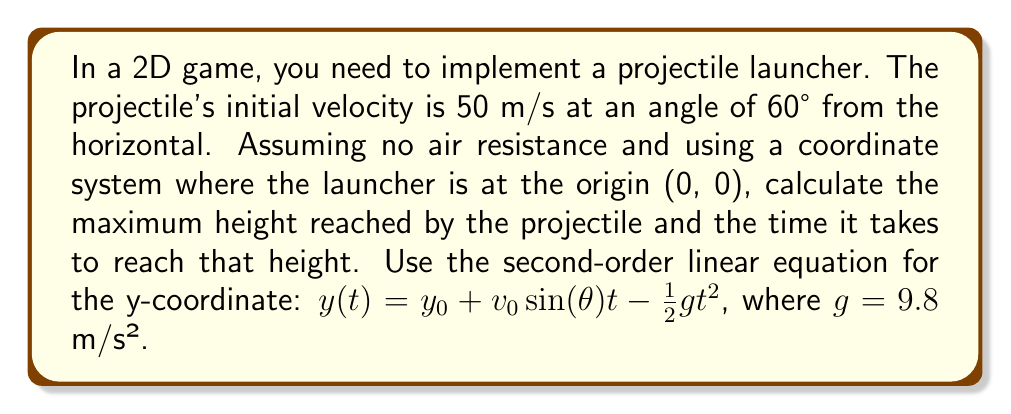Can you solve this math problem? To solve this problem, we'll use the second-order linear equation for the y-coordinate of a projectile:

$$y(t) = y_0 + v_0\sin(\theta)t - \frac{1}{2}gt^2$$

Where:
- $y_0$ is the initial height (0 m in this case)
- $v_0$ is the initial velocity (50 m/s)
- $\theta$ is the launch angle (60°)
- $g$ is the acceleration due to gravity (9.8 m/s²)
- $t$ is time

Step 1: Calculate the vertical component of the initial velocity:
$$v_0\sin(\theta) = 50 \sin(60°) = 50 \cdot \frac{\sqrt{3}}{2} \approx 43.30 \text{ m/s}$$

Step 2: To find the maximum height, we need to find when the vertical velocity is zero. The vertical velocity is given by the derivative of $y(t)$:

$$v_y(t) = v_0\sin(\theta) - gt$$

Set this equal to zero and solve for $t$:

$$0 = 43.30 - 9.8t$$
$$t = \frac{43.30}{9.8} \approx 4.42 \text{ seconds}$$

This is the time it takes to reach the maximum height.

Step 3: Calculate the maximum height by plugging this time back into the original equation:

$$y_{max} = 0 + 43.30 \cdot 4.42 - \frac{1}{2} \cdot 9.8 \cdot 4.42^2$$
$$y_{max} = 191.39 - 95.70 \approx 95.69 \text{ meters}$$
Answer: The maximum height reached by the projectile is approximately 95.69 meters, and it takes approximately 4.42 seconds to reach this height. 